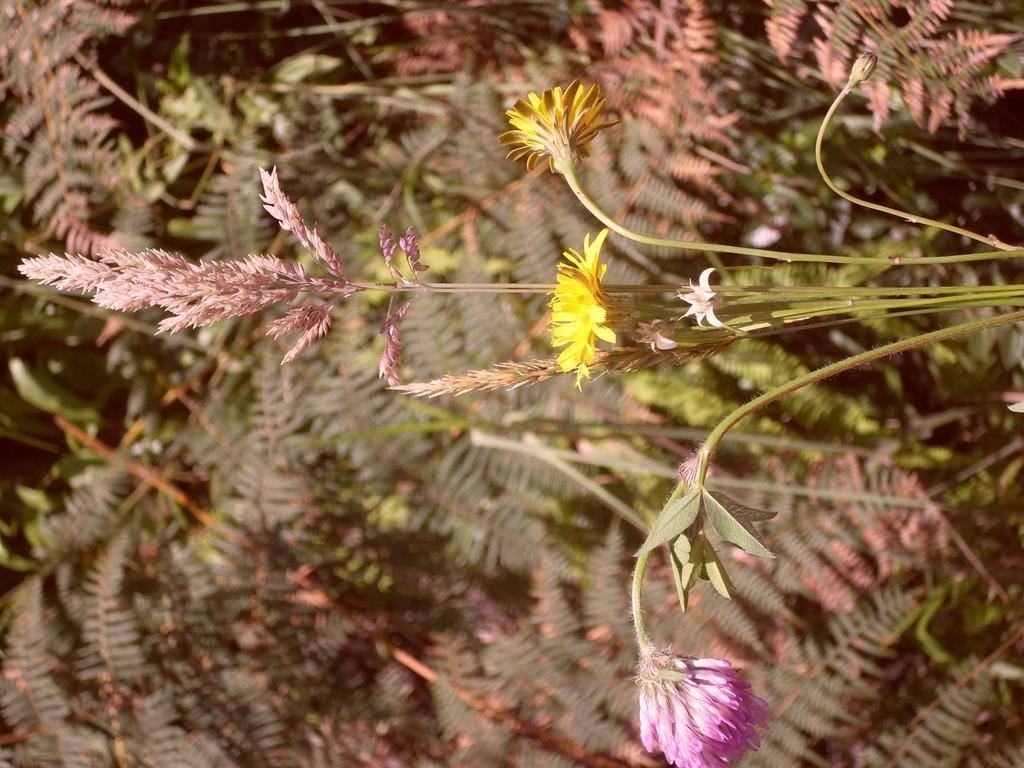How would you summarize this image in a sentence or two? In this image in the foreground there are some flowers, and in the background there are some plants. 